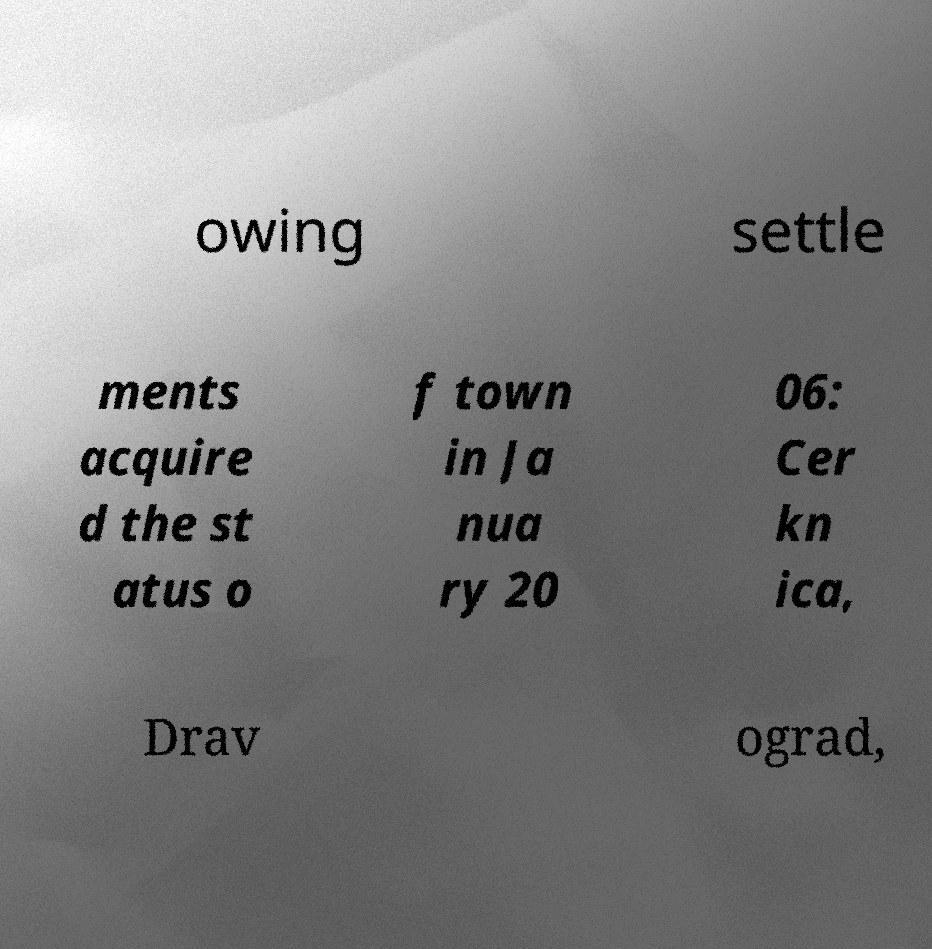What messages or text are displayed in this image? I need them in a readable, typed format. owing settle ments acquire d the st atus o f town in Ja nua ry 20 06: Cer kn ica, Drav ograd, 